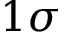<formula> <loc_0><loc_0><loc_500><loc_500>1 \sigma</formula> 